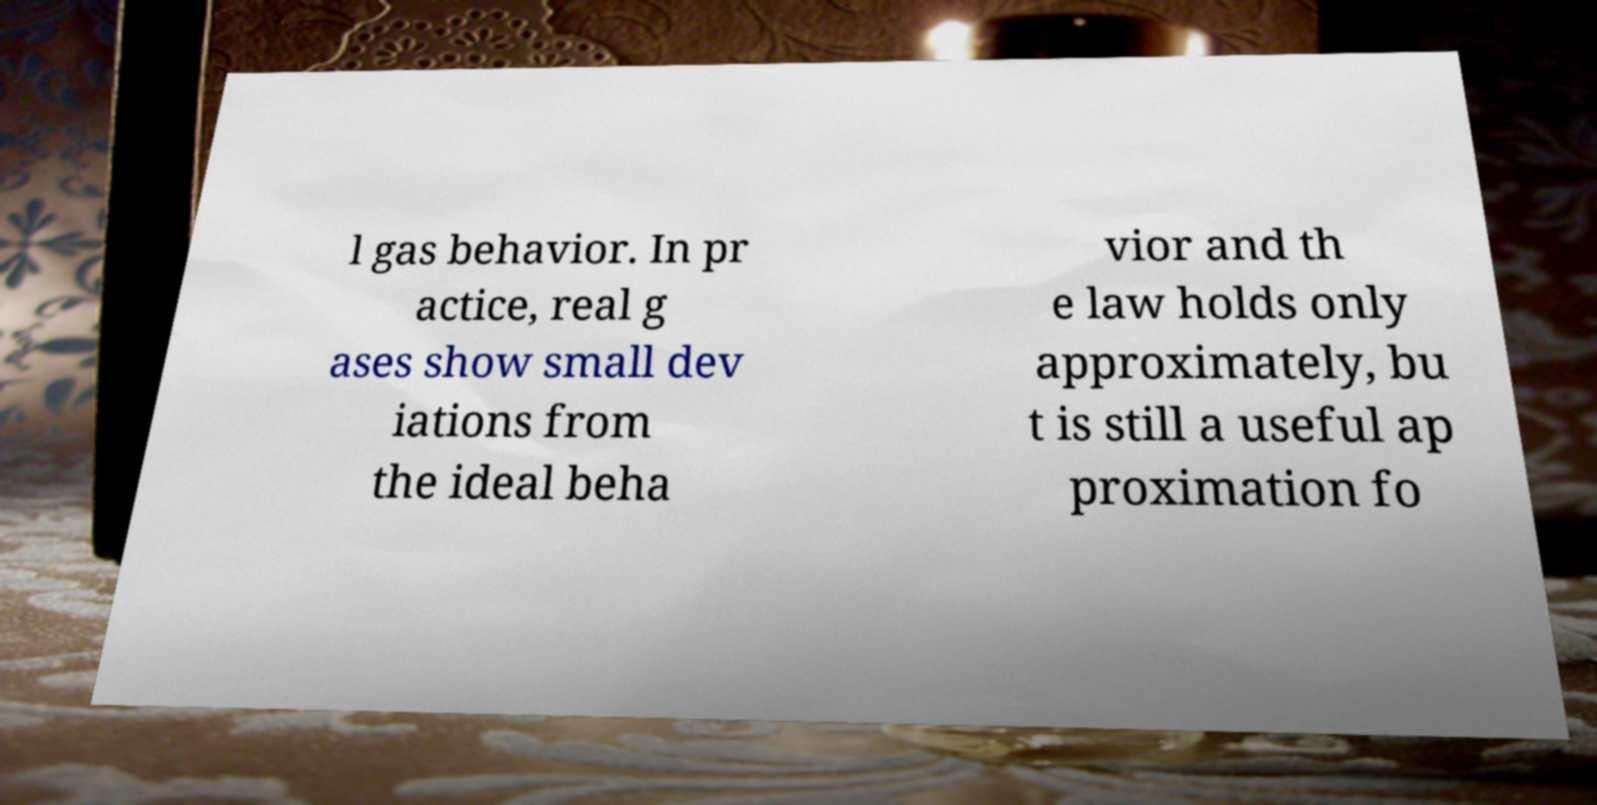Could you extract and type out the text from this image? l gas behavior. In pr actice, real g ases show small dev iations from the ideal beha vior and th e law holds only approximately, bu t is still a useful ap proximation fo 